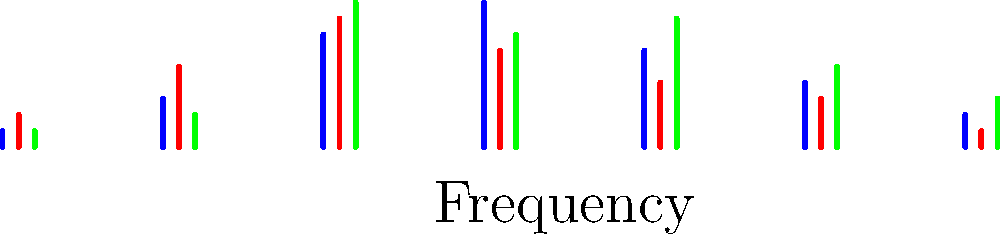Based on the frequency distribution histograms of film soundtracks shown above, which genre typically exhibits the highest amplitude in the mid-frequency range (represented by the central bars) and how might this relate to its emotional impact in music therapy sessions? To answer this question, we need to analyze the frequency distribution histograms for each genre:

1. Observe the central bars (mid-frequency range) for each genre:
   - Action (blue): Shows a peak in the mid-range, but not the highest.
   - Drama (red): Exhibits a high amplitude in the mid-range.
   - Horror (green): Displays the highest amplitude in the mid-range.

2. Identify the genre with the highest mid-range amplitude:
   Horror (green) has the tallest central bar, indicating the highest amplitude in the mid-frequency range.

3. Consider the emotional impact in music therapy:
   - Mid-range frequencies often correspond to the human vocal range and many musical instruments.
   - Higher amplitudes in this range can create a sense of tension, urgency, or emotional intensity.
   - For horror soundtracks, this could evoke feelings of suspense, fear, or anxiety.

4. Therapeutic implications:
   - In music therapy sessions, horror soundtrack elements might be used to:
     a) Help patients confront and process fear or anxiety in a controlled environment.
     b) Provide a cathartic experience for emotional release.
     c) Develop coping strategies for high-stress situations.

5. Contrast with other genres:
   - Action: More balanced across frequencies, potentially useful for energizing sessions.
   - Drama: Moderate mid-range emphasis, possibly beneficial for exploring a range of emotions.

The horror genre's high mid-frequency amplitude can be a powerful tool in music therapy, allowing therapists to work with intense emotions in a structured and purposeful manner.
Answer: Horror; high mid-frequency amplitudes can evoke intense emotions, useful for processing fear and anxiety in therapy. 